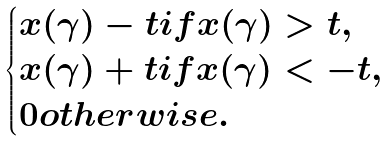Convert formula to latex. <formula><loc_0><loc_0><loc_500><loc_500>\begin{cases} x ( \gamma ) - t i f x ( \gamma ) > t , \\ x ( \gamma ) + t i f x ( \gamma ) < - t , \\ 0 o t h e r w i s e . \end{cases}</formula> 